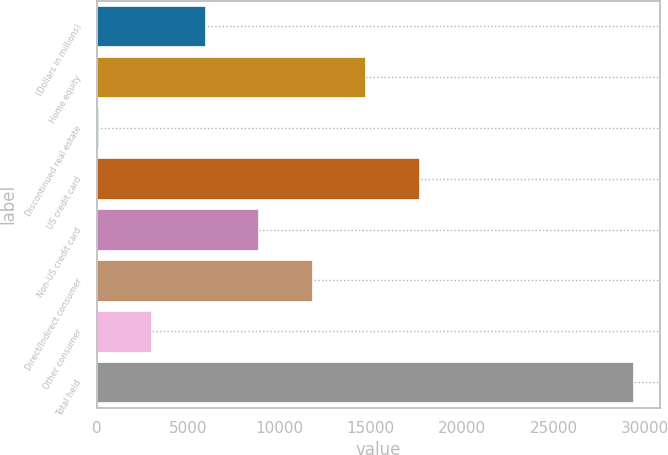Convert chart. <chart><loc_0><loc_0><loc_500><loc_500><bar_chart><fcel>(Dollars in millions)<fcel>Home equity<fcel>Discontinued real estate<fcel>US credit card<fcel>Non-US credit card<fcel>Direct/Indirect consumer<fcel>Other consumer<fcel>Total held<nl><fcel>5924.4<fcel>14709<fcel>68<fcel>17637.2<fcel>8852.6<fcel>11780.8<fcel>2996.2<fcel>29350<nl></chart> 